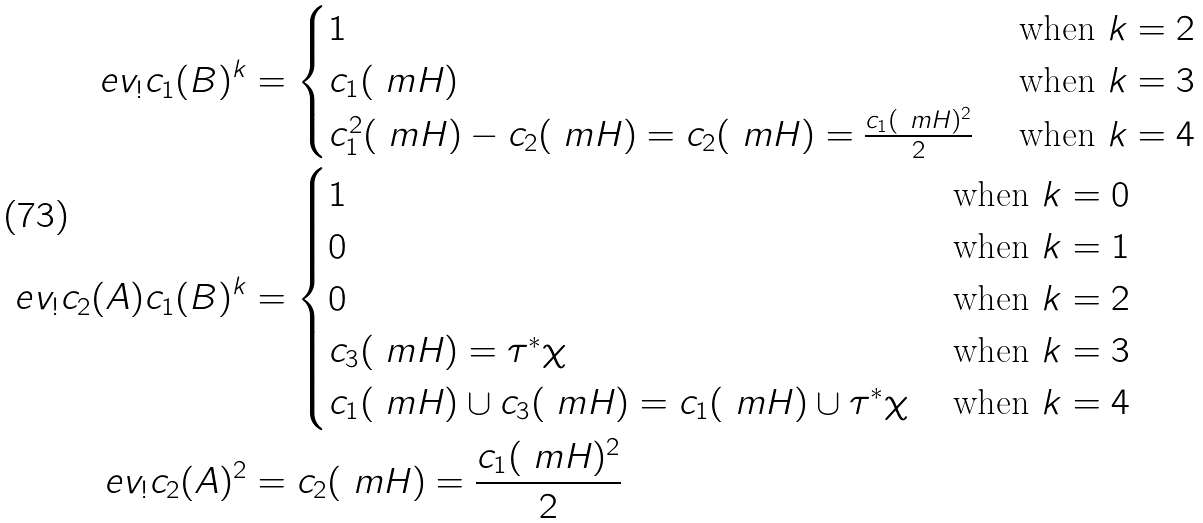Convert formula to latex. <formula><loc_0><loc_0><loc_500><loc_500>\ e v _ { ! } c _ { 1 } ( B ) ^ { k } & = \begin{cases} 1 & \ \text {when} \ k = 2 \\ c _ { 1 } ( \ m H ) & \ \text {when} \ k = 3 \\ c _ { 1 } ^ { 2 } ( \ m H ) - c _ { 2 } ( \ m H ) = c _ { 2 } ( \ m H ) = \frac { c _ { 1 } ( \ m H ) ^ { 2 } } { 2 } & \ \text {when} \ k = 4 \\ \end{cases} \\ \ e v _ { ! } c _ { 2 } ( A ) c _ { 1 } ( B ) ^ { k } & = \begin{cases} 1 & \ \text {when} \ k = 0 \\ 0 & \ \text {when} \ k = 1 \\ 0 & \ \text {when} \ k = 2 \\ c _ { 3 } ( \ m H ) = \tau ^ { * } \chi & \ \text {when} \ k = 3 \\ c _ { 1 } ( \ m H ) \cup c _ { 3 } ( \ m H ) = c _ { 1 } ( \ m H ) \cup \tau ^ { * } \chi & \ \text {when} \ k = 4 \\ \end{cases} \\ \ e v _ { ! } c _ { 2 } ( A ) ^ { 2 } & = c _ { 2 } ( \ m H ) = \frac { c _ { 1 } ( \ m H ) ^ { 2 } } { 2 }</formula> 